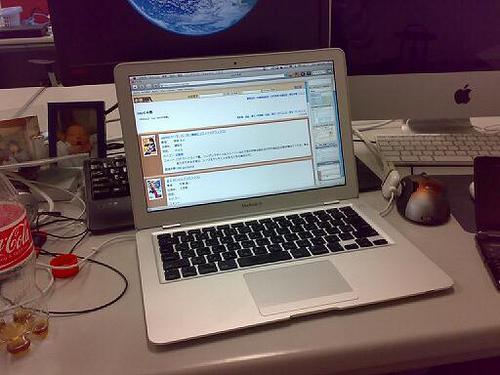How many keyboards are there?
Give a very brief answer. 3. How many laptops are there?
Give a very brief answer. 1. How many full length fingers are visible?
Give a very brief answer. 0. How many keyboards are in the picture?
Give a very brief answer. 3. How many boats are on the water?
Give a very brief answer. 0. 